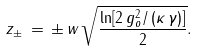<formula> <loc_0><loc_0><loc_500><loc_500>z _ { \pm } \, = \, \pm \, w \, \sqrt { \frac { \ln [ 2 \, g _ { o } ^ { 2 } / \left ( \kappa \, \gamma \right ) ] } { 2 } } .</formula> 